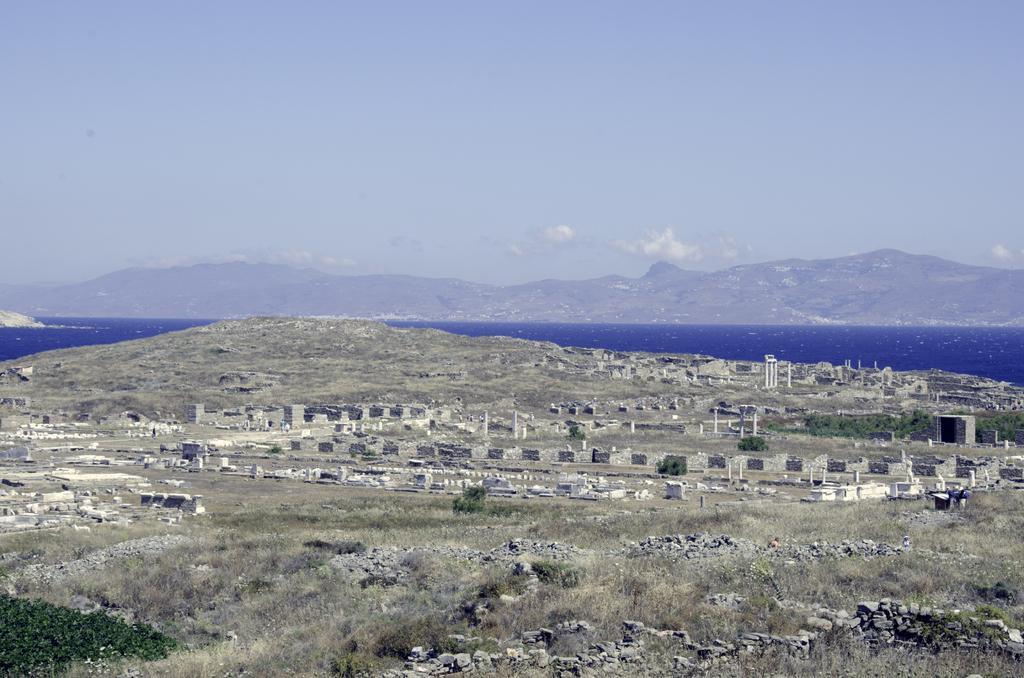In one or two sentences, can you explain what this image depicts? In this image I can see few dry grass, stones, poles, mountains,trees and the water. It looks like construction site. 